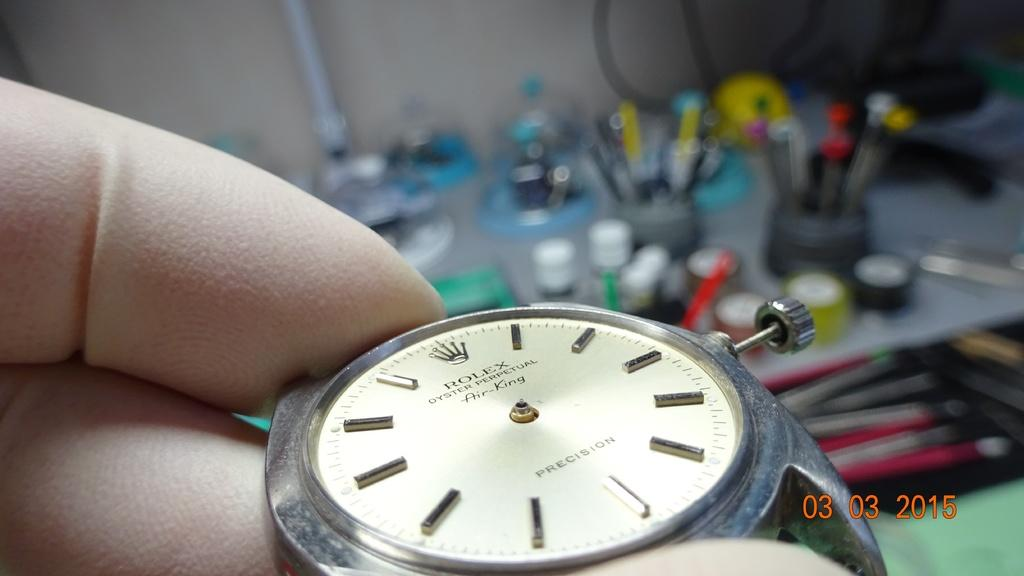<image>
Provide a brief description of the given image. A white and silver Rolex Oyster Perpetual Air King. 